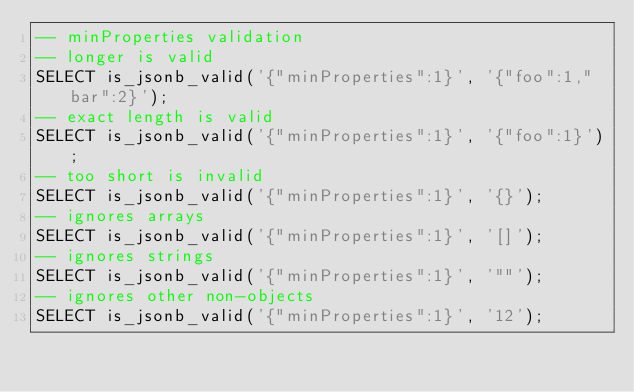Convert code to text. <code><loc_0><loc_0><loc_500><loc_500><_SQL_>-- minProperties validation
-- longer is valid
SELECT is_jsonb_valid('{"minProperties":1}', '{"foo":1,"bar":2}');
-- exact length is valid
SELECT is_jsonb_valid('{"minProperties":1}', '{"foo":1}');
-- too short is invalid
SELECT is_jsonb_valid('{"minProperties":1}', '{}');
-- ignores arrays
SELECT is_jsonb_valid('{"minProperties":1}', '[]');
-- ignores strings
SELECT is_jsonb_valid('{"minProperties":1}', '""');
-- ignores other non-objects
SELECT is_jsonb_valid('{"minProperties":1}', '12');</code> 